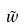<formula> <loc_0><loc_0><loc_500><loc_500>\tilde { w }</formula> 